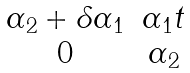Convert formula to latex. <formula><loc_0><loc_0><loc_500><loc_500>\begin{matrix} \alpha _ { 2 } + \delta \alpha _ { 1 } & \alpha _ { 1 } t \\ 0 & \alpha _ { 2 } \\ \end{matrix}</formula> 